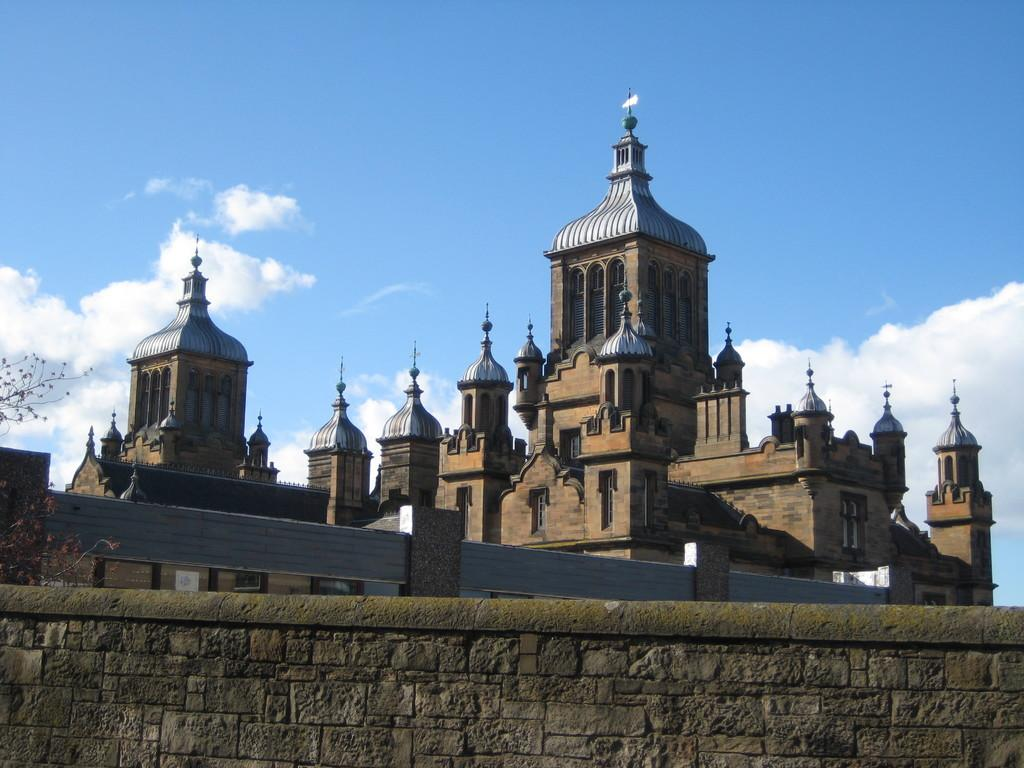What type of structure is in the image? There is a building in the image. What feature can be seen on the building? The building has windows. What natural element is present in the image? There is a tree in the image. What architectural element is visible in the image? There is a wall in the image. What can be seen in the background of the image? The sky is visible in the background of the image. What atmospheric condition is present in the sky? Clouds are present in the sky. How many mice are sitting on the jar in the image? There are no mice or jars present in the image. What type of gate can be seen in the image? There is no gate present in the image. 